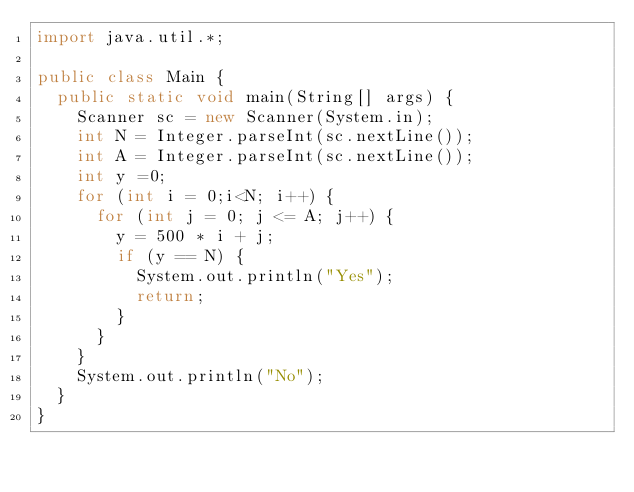Convert code to text. <code><loc_0><loc_0><loc_500><loc_500><_Java_>import java.util.*;

public class Main {
  public static void main(String[] args) {
    Scanner sc = new Scanner(System.in);
    int N = Integer.parseInt(sc.nextLine());
    int A = Integer.parseInt(sc.nextLine());
    int y =0;
    for (int i = 0;i<N; i++) {
      for (int j = 0; j <= A; j++) {
        y = 500 * i + j;
        if (y == N) {
          System.out.println("Yes");
          return;
        }
      }
    }
    System.out.println("No");
  }
}</code> 